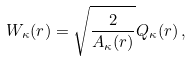Convert formula to latex. <formula><loc_0><loc_0><loc_500><loc_500>W _ { \kappa } ( r ) = \sqrt { \frac { 2 } { A _ { \kappa } ( r ) } } Q _ { \kappa } ( r ) \, ,</formula> 